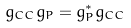<formula> <loc_0><loc_0><loc_500><loc_500>g _ { C C } g _ { P } = g _ { P } ^ { * } g _ { C C }</formula> 